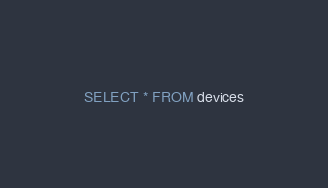Convert code to text. <code><loc_0><loc_0><loc_500><loc_500><_SQL_>SELECT * FROM devices</code> 